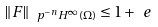Convert formula to latex. <formula><loc_0><loc_0><loc_500><loc_500>\| F \| _ { \ p ^ { - n } H ^ { \infty } ( \Omega ) } \leq 1 + \ e</formula> 